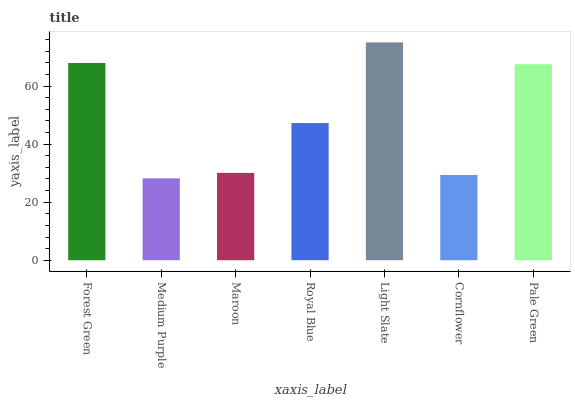Is Medium Purple the minimum?
Answer yes or no. Yes. Is Light Slate the maximum?
Answer yes or no. Yes. Is Maroon the minimum?
Answer yes or no. No. Is Maroon the maximum?
Answer yes or no. No. Is Maroon greater than Medium Purple?
Answer yes or no. Yes. Is Medium Purple less than Maroon?
Answer yes or no. Yes. Is Medium Purple greater than Maroon?
Answer yes or no. No. Is Maroon less than Medium Purple?
Answer yes or no. No. Is Royal Blue the high median?
Answer yes or no. Yes. Is Royal Blue the low median?
Answer yes or no. Yes. Is Pale Green the high median?
Answer yes or no. No. Is Cornflower the low median?
Answer yes or no. No. 